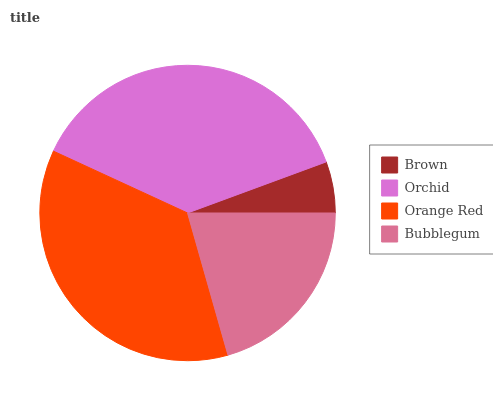Is Brown the minimum?
Answer yes or no. Yes. Is Orchid the maximum?
Answer yes or no. Yes. Is Orange Red the minimum?
Answer yes or no. No. Is Orange Red the maximum?
Answer yes or no. No. Is Orchid greater than Orange Red?
Answer yes or no. Yes. Is Orange Red less than Orchid?
Answer yes or no. Yes. Is Orange Red greater than Orchid?
Answer yes or no. No. Is Orchid less than Orange Red?
Answer yes or no. No. Is Orange Red the high median?
Answer yes or no. Yes. Is Bubblegum the low median?
Answer yes or no. Yes. Is Bubblegum the high median?
Answer yes or no. No. Is Brown the low median?
Answer yes or no. No. 